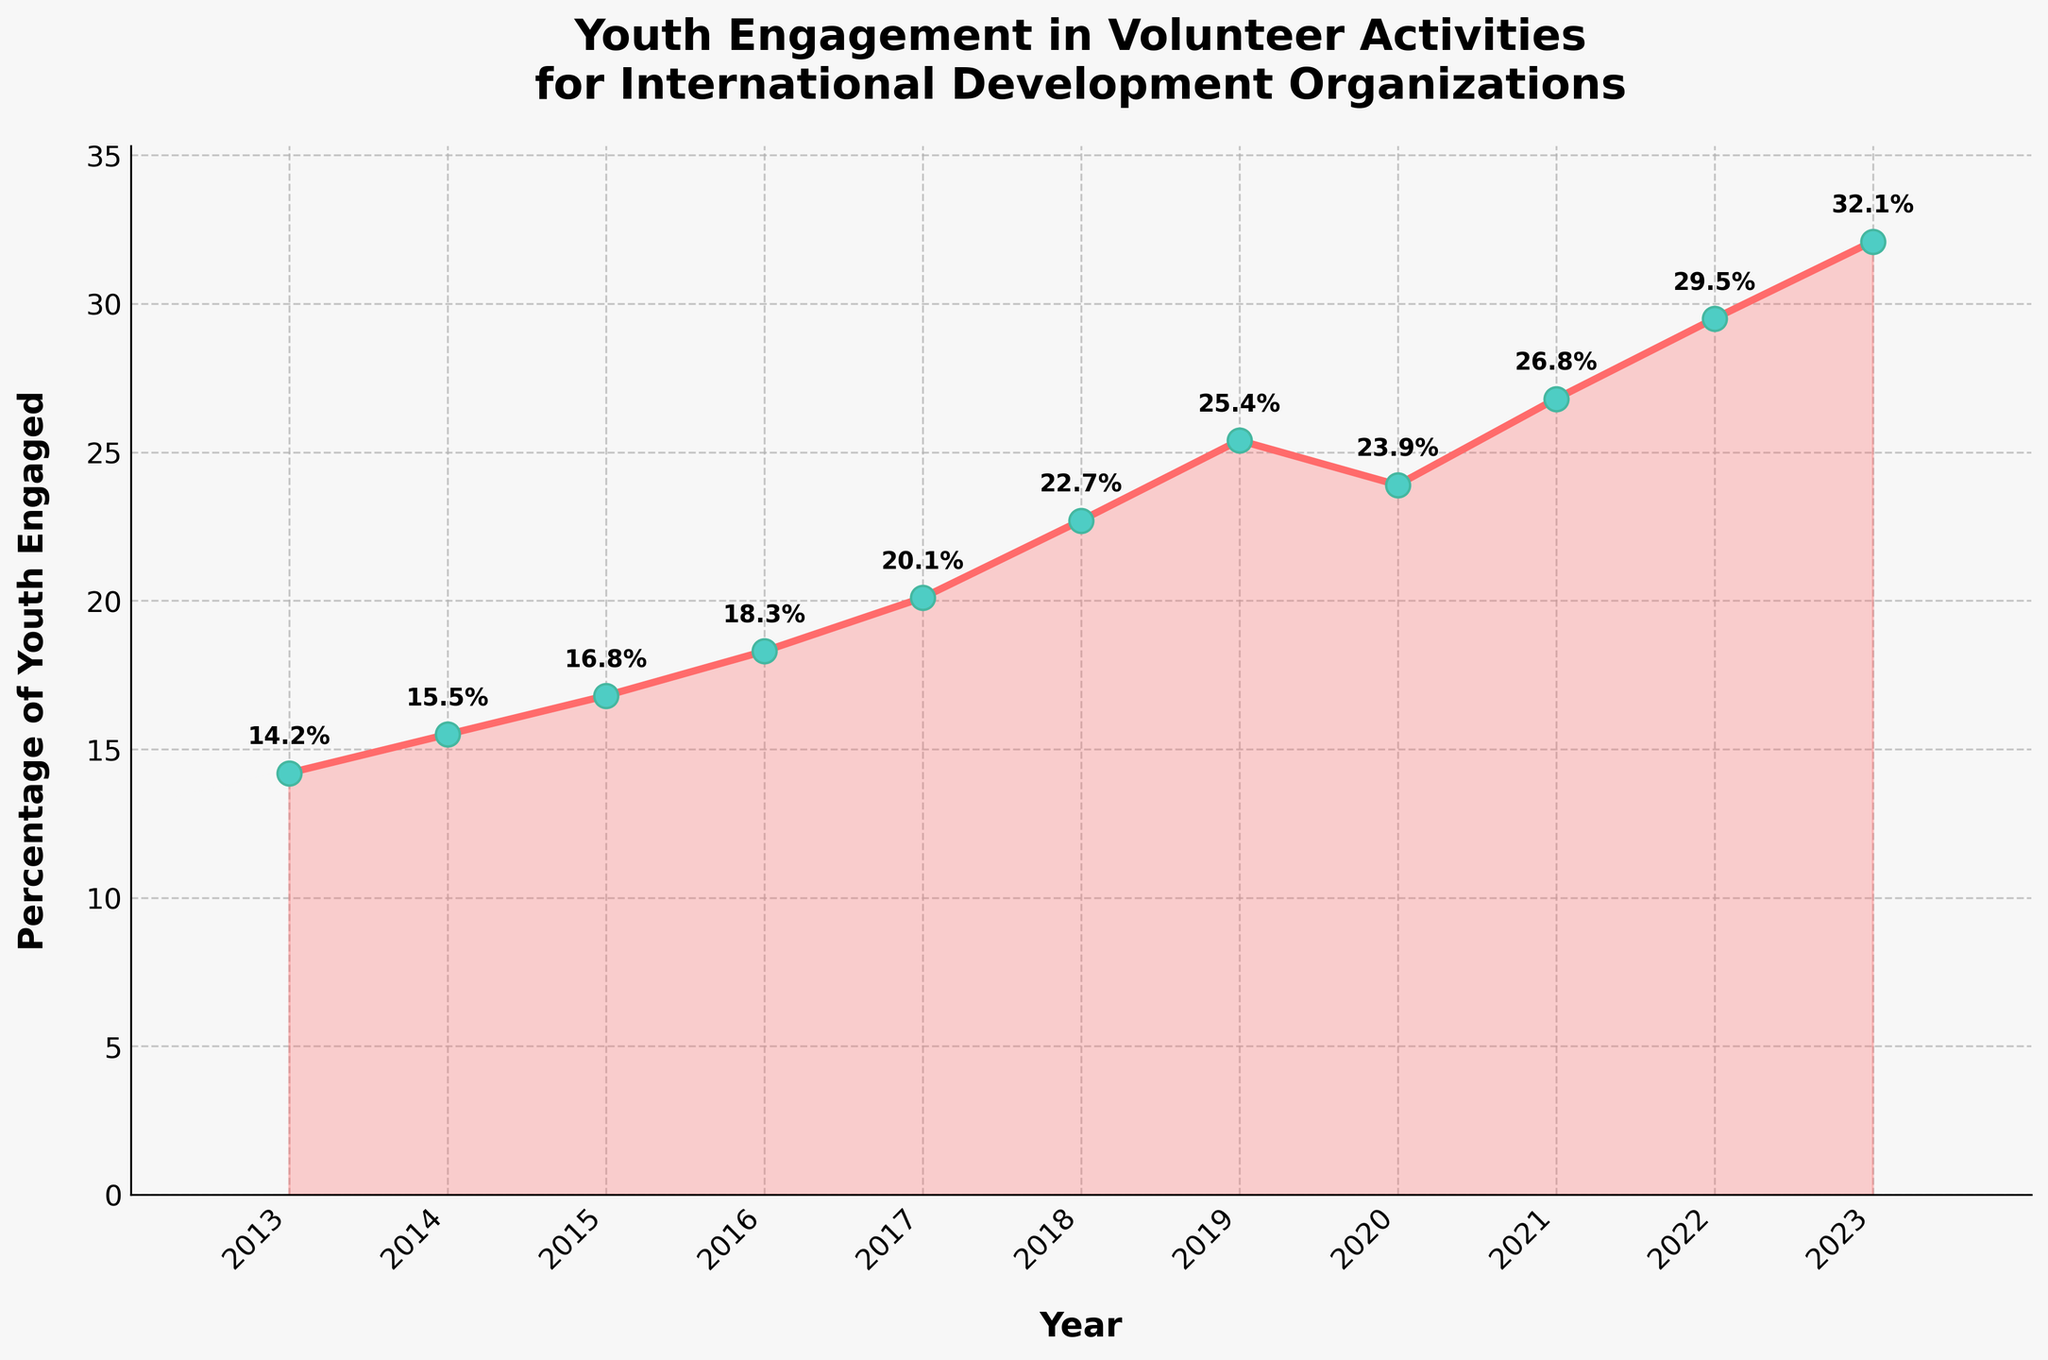What's the percentage of youth engaged in volunteer activities in 2023? Look at the value labeled for the year 2023 on the x-axis. The value annotated is 32.1%.
Answer: 32.1% How did youth engagement change from 2019 to 2020? Observe the values for 2019 and 2020. In 2019, the percentage is 25.4%, and in 2020, it's 23.9%. Calculate the difference: 25.4% - 23.9% = 1.5%. Youth engagement decreased.
Answer: Decreased by 1.5% Which year had the highest percentage increase in youth engagement compared to the previous year? Compare the year-to-year differences: 2013 to 2014 (1.3%), 2014 to 2015 (1.3%), ..., 2022 to 2023 (2.6%). The largest increase is between 2022 and 2023 with 2.6%.
Answer: 2022 to 2023 What is the average percentage of youth engagement over the decade? Add all the percentages from 2013 to 2023 and then divide by the number of years, (14.2 + 15.5 + 16.8 + 18.3 + 20.1 + 22.7 + 25.4 + 23.9 + 26.8 + 29.5 + 32.1) / 11. This gives an average of 21.2%.
Answer: 21.2% How does the engagement trend visually appear in terms of the line's overall direction? Observe the general direction of the line plot. The trend generally increases from left to right except for a slight dip in 2020. This indicates an overall upward trend.
Answer: Upward trend Did youth engagement ever decrease from one year to the next? Check the plot for any downward movement in the line. Between 2019 and 2020, there is a noticeable drop from 25.4% to 23.9%.
Answer: Yes, between 2019 and 2020 What visual feature marks each data point on the line? Each year’s data point on the line is marked by a circle (marker) with a specific color highlighting it.
Answer: Circle markers with contrasting colors Compare the youth engagement percentages between the first and last years shown. How much did it increase? The percentage in 2013 is 14.2%, and in 2023 it's 32.1%. Calculate the increase: 32.1% - 14.2% = 17.9%.
Answer: Increased by 17.9% Which year had the second highest engagement percentage, and what was that percentage? Inspect the annotated values to find the second highest percentage. 32.1% (2023) is the highest, and the next highest is 29.5% in 2022.
Answer: 2022, 29.5% How many years had an engagement percentage above 25%? Count the number of years with percentages above 25%. These are 2019, 2020, 2021, 2022, and 2023, totaling 5 years.
Answer: 5 years 